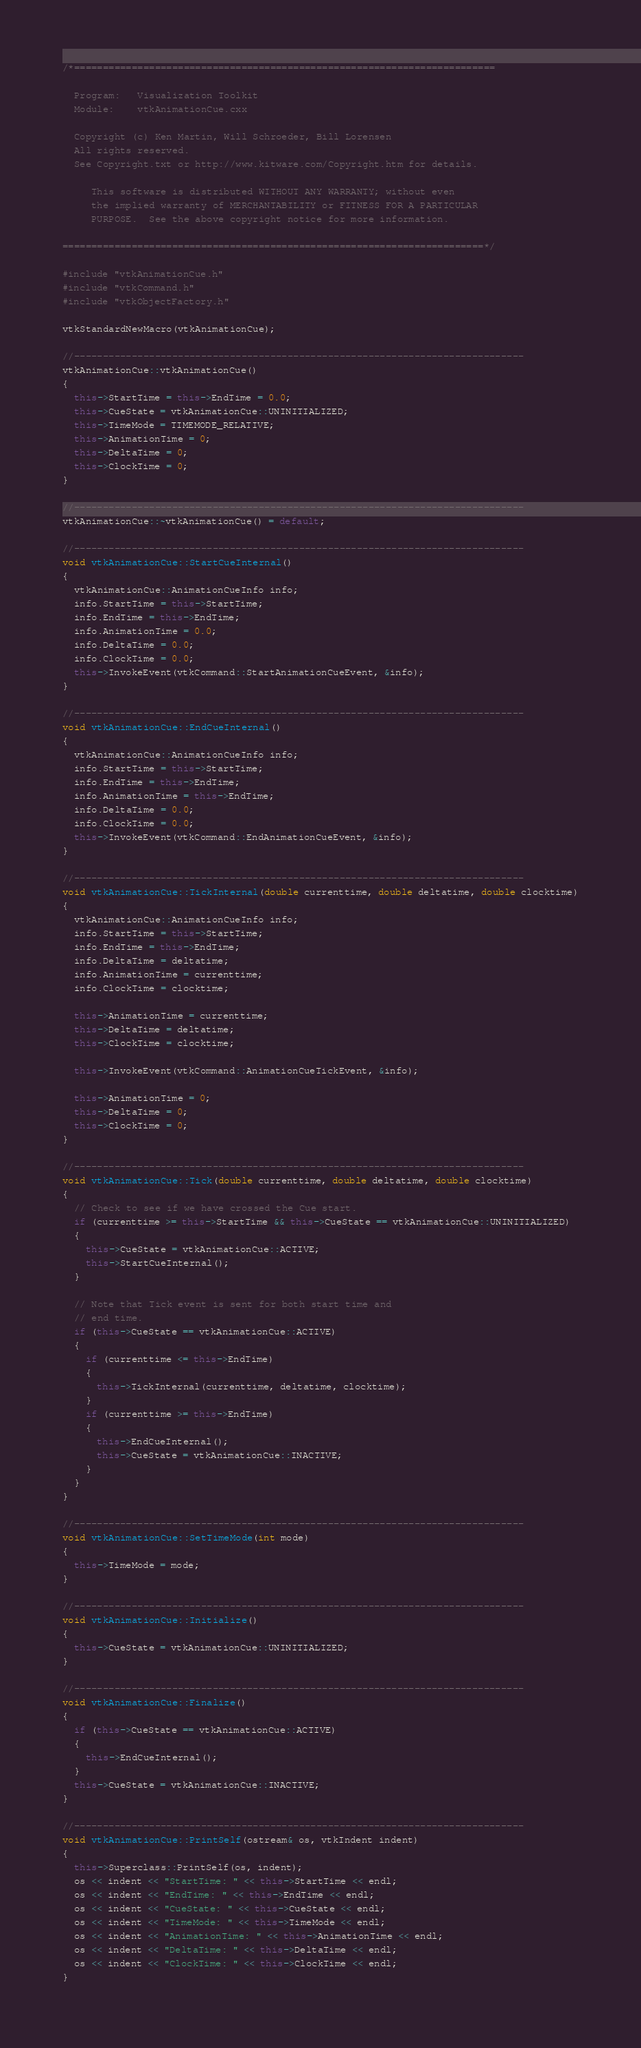Convert code to text. <code><loc_0><loc_0><loc_500><loc_500><_C++_>/*=========================================================================

  Program:   Visualization Toolkit
  Module:    vtkAnimationCue.cxx

  Copyright (c) Ken Martin, Will Schroeder, Bill Lorensen
  All rights reserved.
  See Copyright.txt or http://www.kitware.com/Copyright.htm for details.

     This software is distributed WITHOUT ANY WARRANTY; without even
     the implied warranty of MERCHANTABILITY or FITNESS FOR A PARTICULAR
     PURPOSE.  See the above copyright notice for more information.

=========================================================================*/

#include "vtkAnimationCue.h"
#include "vtkCommand.h"
#include "vtkObjectFactory.h"

vtkStandardNewMacro(vtkAnimationCue);

//------------------------------------------------------------------------------
vtkAnimationCue::vtkAnimationCue()
{
  this->StartTime = this->EndTime = 0.0;
  this->CueState = vtkAnimationCue::UNINITIALIZED;
  this->TimeMode = TIMEMODE_RELATIVE;
  this->AnimationTime = 0;
  this->DeltaTime = 0;
  this->ClockTime = 0;
}

//------------------------------------------------------------------------------
vtkAnimationCue::~vtkAnimationCue() = default;

//------------------------------------------------------------------------------
void vtkAnimationCue::StartCueInternal()
{
  vtkAnimationCue::AnimationCueInfo info;
  info.StartTime = this->StartTime;
  info.EndTime = this->EndTime;
  info.AnimationTime = 0.0;
  info.DeltaTime = 0.0;
  info.ClockTime = 0.0;
  this->InvokeEvent(vtkCommand::StartAnimationCueEvent, &info);
}

//------------------------------------------------------------------------------
void vtkAnimationCue::EndCueInternal()
{
  vtkAnimationCue::AnimationCueInfo info;
  info.StartTime = this->StartTime;
  info.EndTime = this->EndTime;
  info.AnimationTime = this->EndTime;
  info.DeltaTime = 0.0;
  info.ClockTime = 0.0;
  this->InvokeEvent(vtkCommand::EndAnimationCueEvent, &info);
}

//------------------------------------------------------------------------------
void vtkAnimationCue::TickInternal(double currenttime, double deltatime, double clocktime)
{
  vtkAnimationCue::AnimationCueInfo info;
  info.StartTime = this->StartTime;
  info.EndTime = this->EndTime;
  info.DeltaTime = deltatime;
  info.AnimationTime = currenttime;
  info.ClockTime = clocktime;

  this->AnimationTime = currenttime;
  this->DeltaTime = deltatime;
  this->ClockTime = clocktime;

  this->InvokeEvent(vtkCommand::AnimationCueTickEvent, &info);

  this->AnimationTime = 0;
  this->DeltaTime = 0;
  this->ClockTime = 0;
}

//------------------------------------------------------------------------------
void vtkAnimationCue::Tick(double currenttime, double deltatime, double clocktime)
{
  // Check to see if we have crossed the Cue start.
  if (currenttime >= this->StartTime && this->CueState == vtkAnimationCue::UNINITIALIZED)
  {
    this->CueState = vtkAnimationCue::ACTIVE;
    this->StartCueInternal();
  }

  // Note that Tick event is sent for both start time and
  // end time.
  if (this->CueState == vtkAnimationCue::ACTIVE)
  {
    if (currenttime <= this->EndTime)
    {
      this->TickInternal(currenttime, deltatime, clocktime);
    }
    if (currenttime >= this->EndTime)
    {
      this->EndCueInternal();
      this->CueState = vtkAnimationCue::INACTIVE;
    }
  }
}

//------------------------------------------------------------------------------
void vtkAnimationCue::SetTimeMode(int mode)
{
  this->TimeMode = mode;
}

//------------------------------------------------------------------------------
void vtkAnimationCue::Initialize()
{
  this->CueState = vtkAnimationCue::UNINITIALIZED;
}

//------------------------------------------------------------------------------
void vtkAnimationCue::Finalize()
{
  if (this->CueState == vtkAnimationCue::ACTIVE)
  {
    this->EndCueInternal();
  }
  this->CueState = vtkAnimationCue::INACTIVE;
}

//------------------------------------------------------------------------------
void vtkAnimationCue::PrintSelf(ostream& os, vtkIndent indent)
{
  this->Superclass::PrintSelf(os, indent);
  os << indent << "StartTime: " << this->StartTime << endl;
  os << indent << "EndTime: " << this->EndTime << endl;
  os << indent << "CueState: " << this->CueState << endl;
  os << indent << "TimeMode: " << this->TimeMode << endl;
  os << indent << "AnimationTime: " << this->AnimationTime << endl;
  os << indent << "DeltaTime: " << this->DeltaTime << endl;
  os << indent << "ClockTime: " << this->ClockTime << endl;
}
</code> 